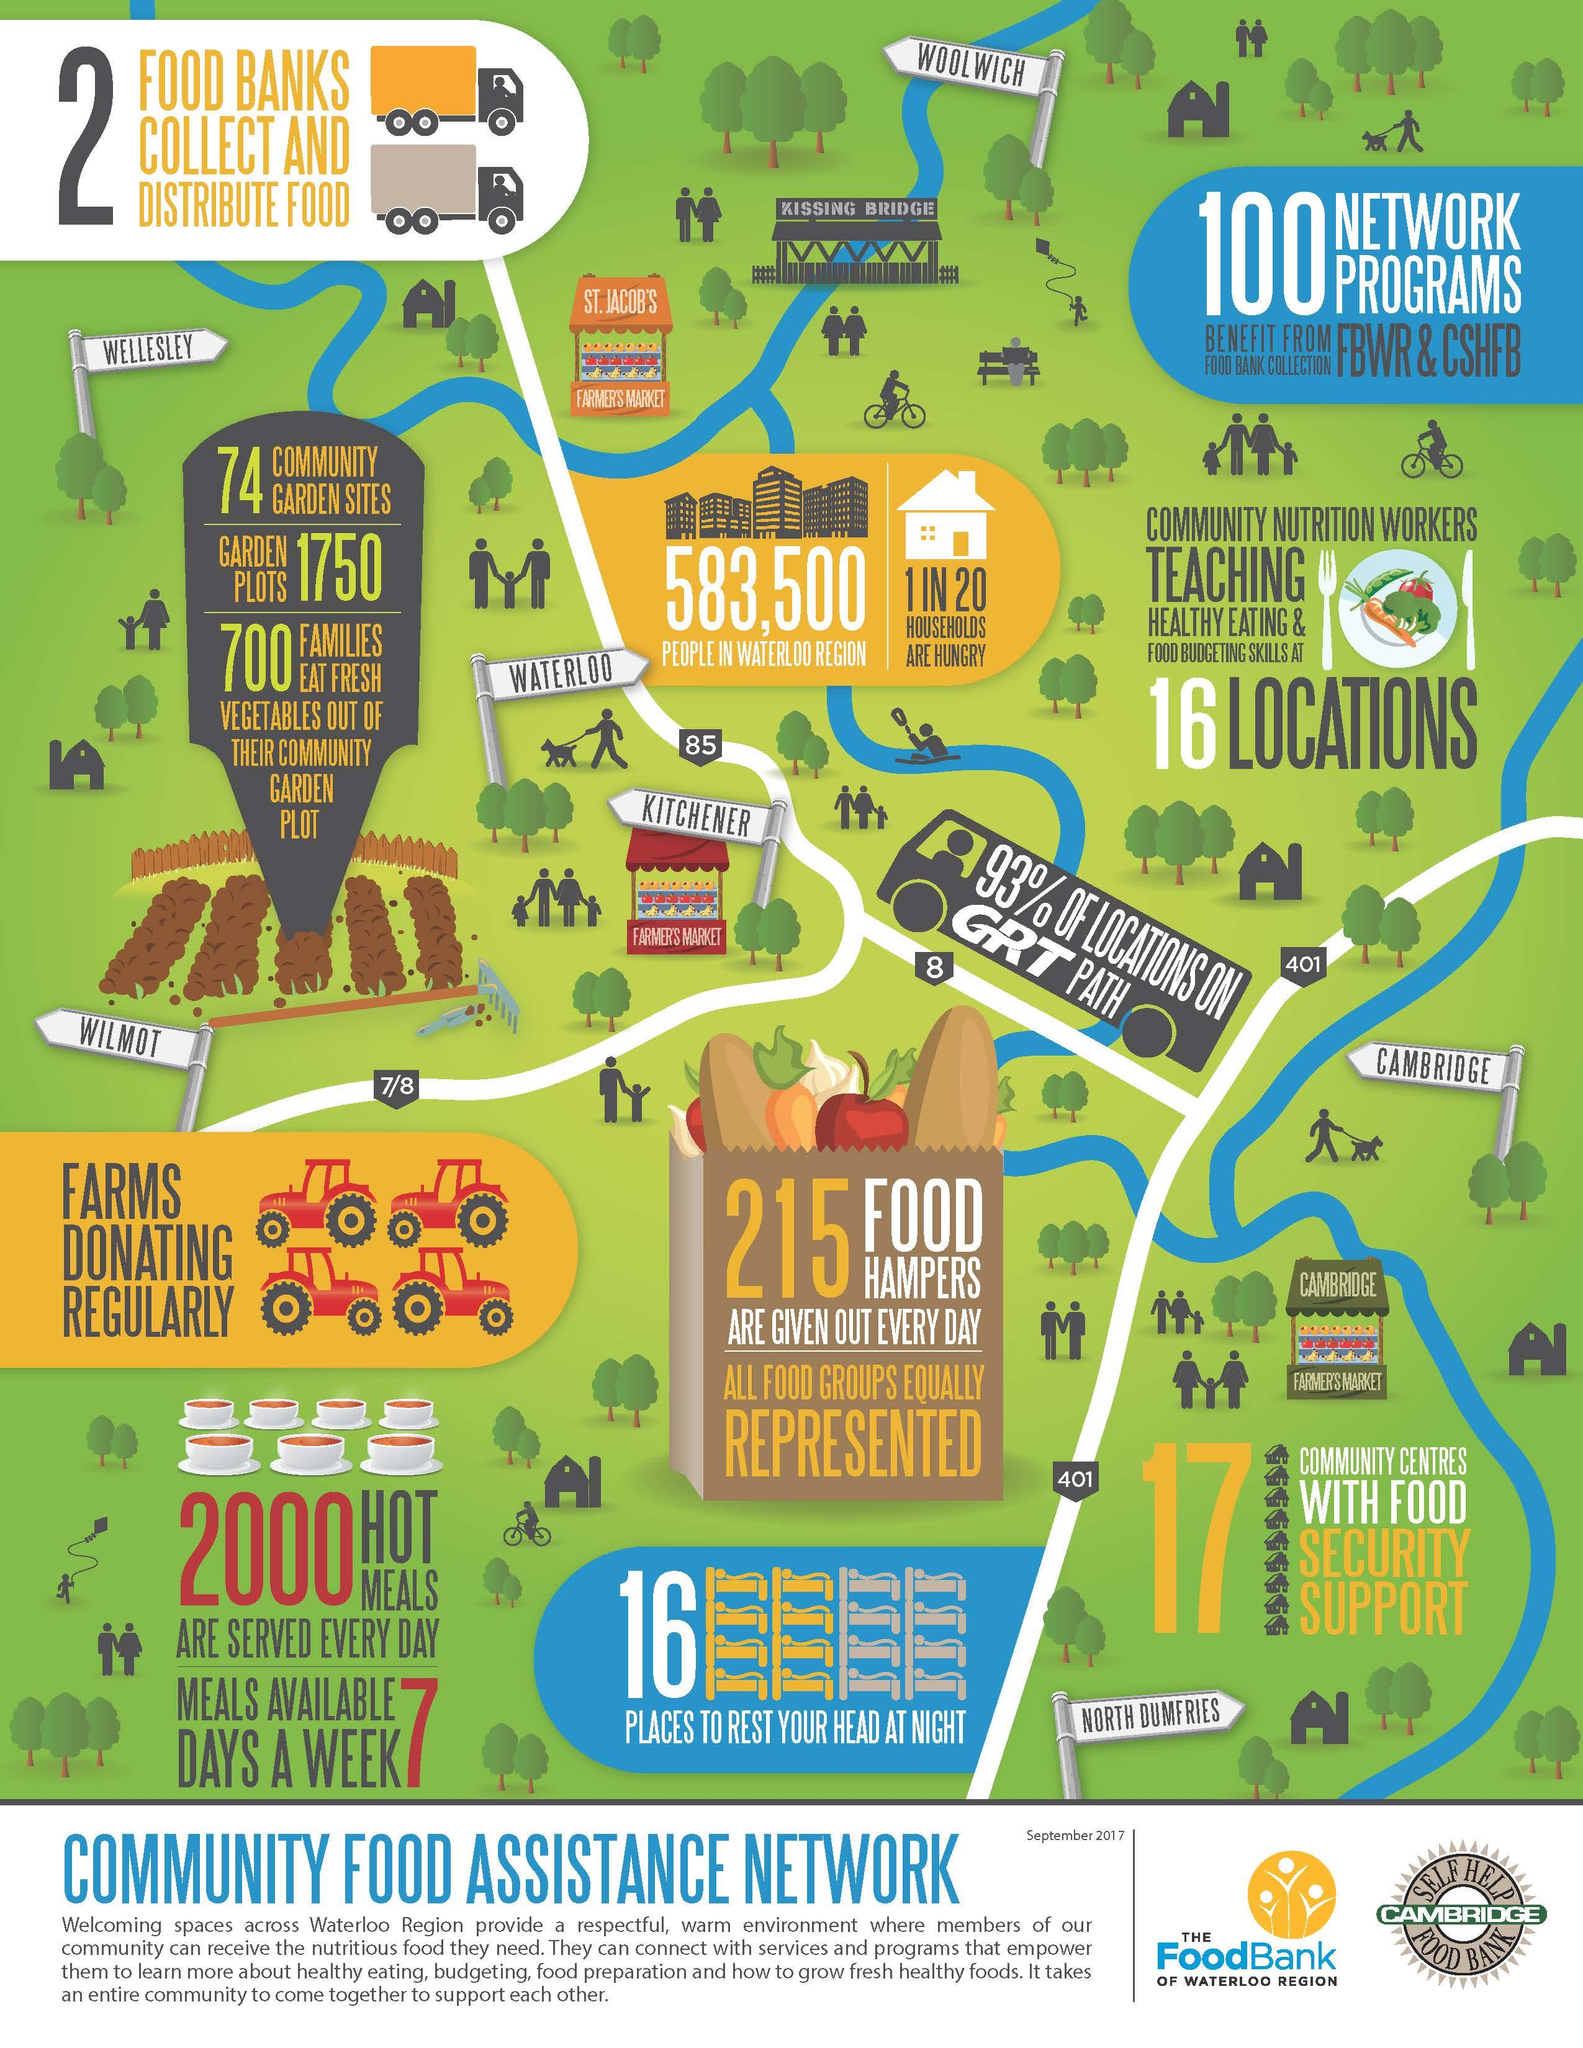Outline some significant characteristics in this image. There are three farmers markets depicted in the image. 